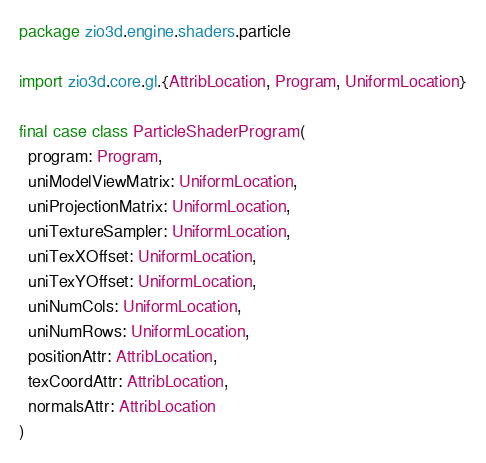<code> <loc_0><loc_0><loc_500><loc_500><_Scala_>package zio3d.engine.shaders.particle

import zio3d.core.gl.{AttribLocation, Program, UniformLocation}

final case class ParticleShaderProgram(
  program: Program,
  uniModelViewMatrix: UniformLocation,
  uniProjectionMatrix: UniformLocation,
  uniTextureSampler: UniformLocation,
  uniTexXOffset: UniformLocation,
  uniTexYOffset: UniformLocation,
  uniNumCols: UniformLocation,
  uniNumRows: UniformLocation,
  positionAttr: AttribLocation,
  texCoordAttr: AttribLocation,
  normalsAttr: AttribLocation
)
</code> 